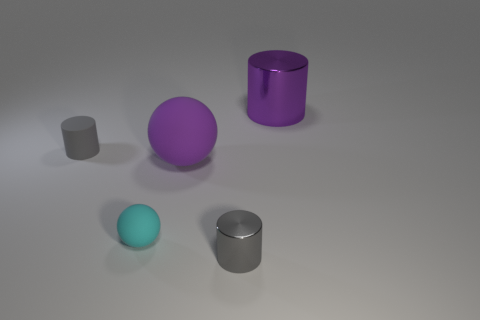Add 4 purple balls. How many objects exist? 9 Subtract all tiny gray cylinders. How many cylinders are left? 1 Add 1 gray rubber balls. How many gray rubber balls exist? 1 Subtract all purple spheres. How many spheres are left? 1 Subtract 1 purple spheres. How many objects are left? 4 Subtract all balls. How many objects are left? 3 Subtract 2 cylinders. How many cylinders are left? 1 Subtract all green spheres. Subtract all green blocks. How many spheres are left? 2 Subtract all blue cylinders. How many purple balls are left? 1 Subtract all small matte objects. Subtract all big gray balls. How many objects are left? 3 